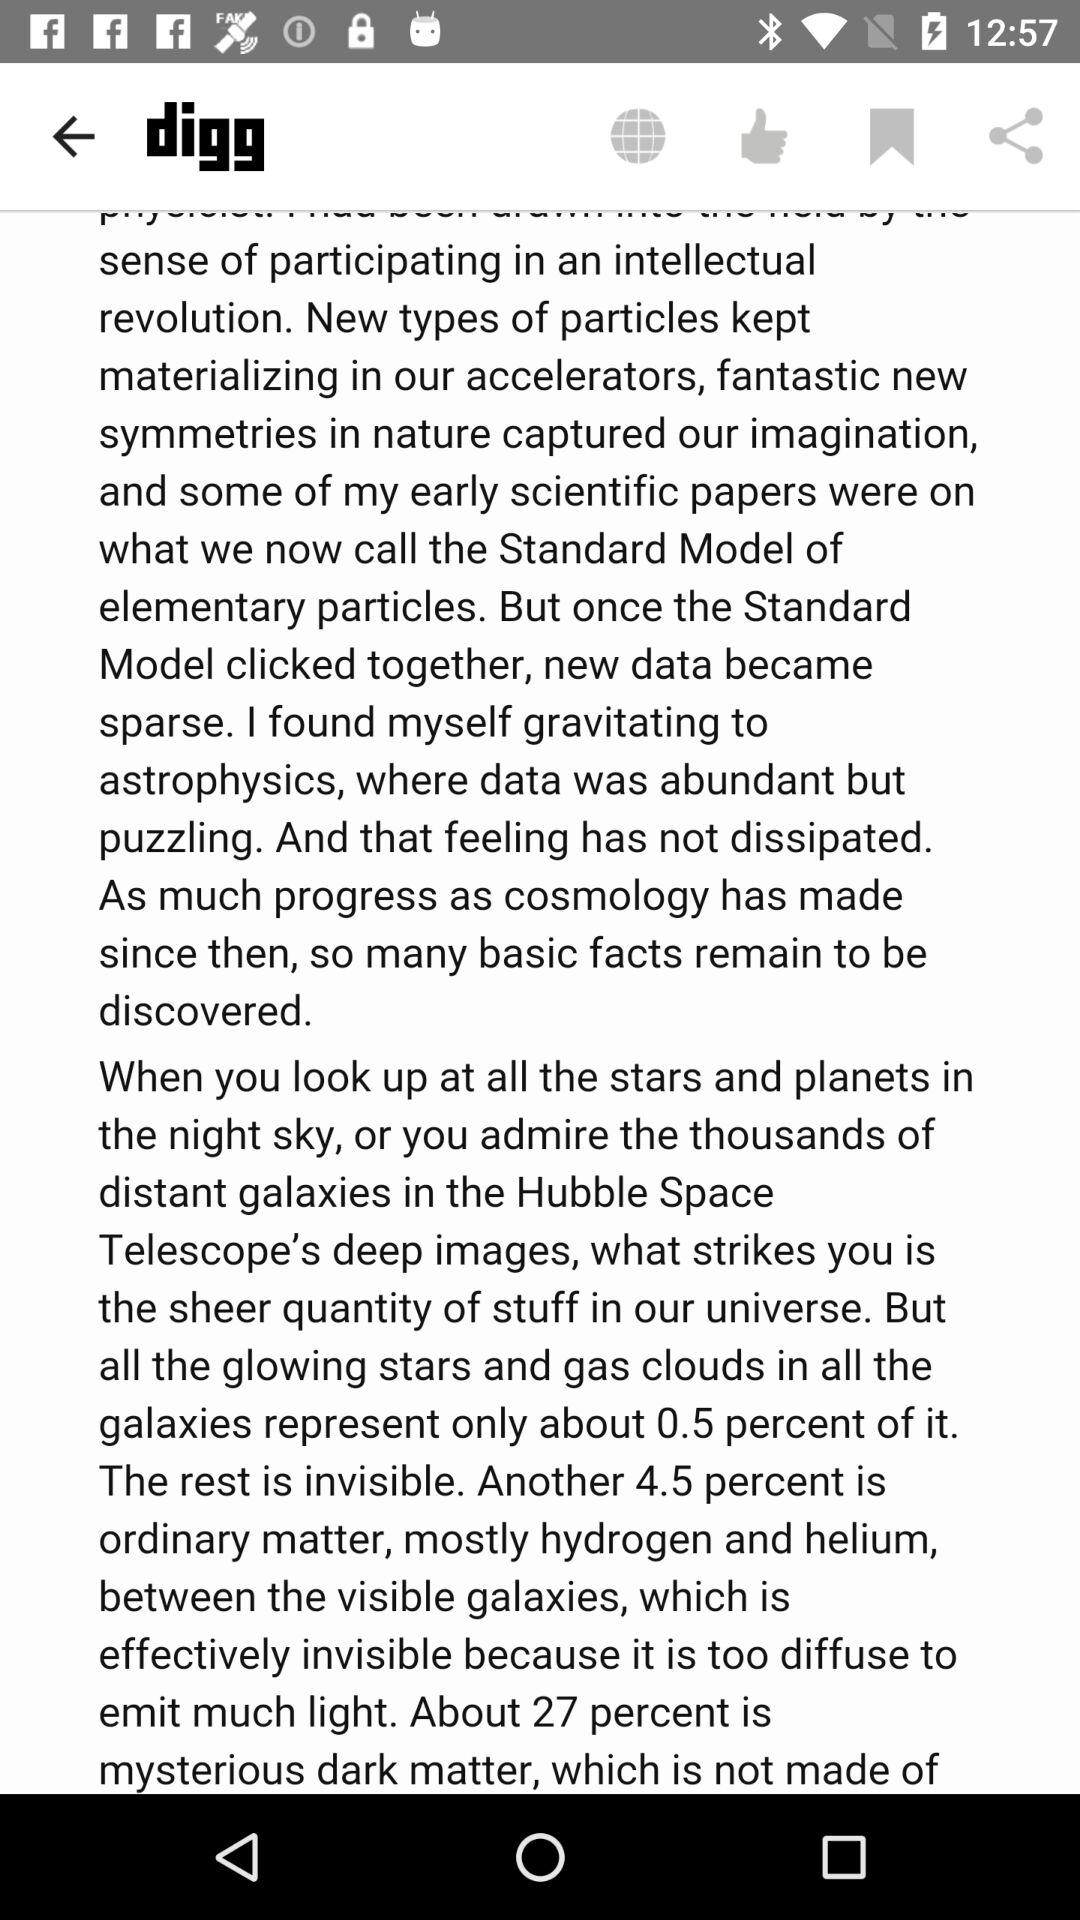What is the name of the application? The name of the application is "digg". 